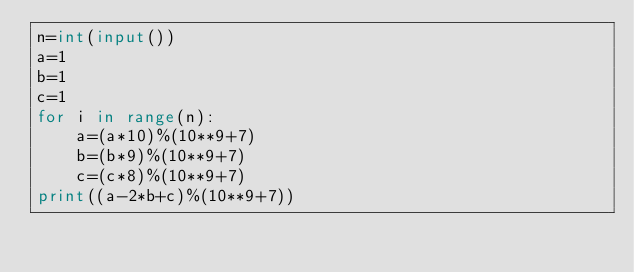Convert code to text. <code><loc_0><loc_0><loc_500><loc_500><_Python_>n=int(input())
a=1
b=1
c=1
for i in range(n):
    a=(a*10)%(10**9+7)
    b=(b*9)%(10**9+7)
    c=(c*8)%(10**9+7)
print((a-2*b+c)%(10**9+7))</code> 